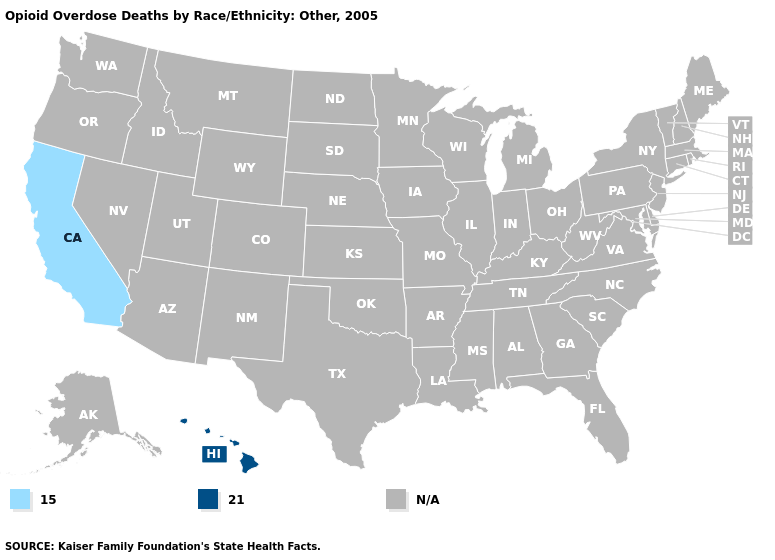What is the value of Louisiana?
Be succinct. N/A. What is the value of New York?
Concise answer only. N/A. What is the value of Alabama?
Answer briefly. N/A. What is the lowest value in the West?
Write a very short answer. 15.0. What is the value of Alaska?
Be succinct. N/A. What is the highest value in the West ?
Keep it brief. 21.0. Does California have the highest value in the USA?
Quick response, please. No. Name the states that have a value in the range 15.0?
Answer briefly. California. Name the states that have a value in the range N/A?
Keep it brief. Alabama, Alaska, Arizona, Arkansas, Colorado, Connecticut, Delaware, Florida, Georgia, Idaho, Illinois, Indiana, Iowa, Kansas, Kentucky, Louisiana, Maine, Maryland, Massachusetts, Michigan, Minnesota, Mississippi, Missouri, Montana, Nebraska, Nevada, New Hampshire, New Jersey, New Mexico, New York, North Carolina, North Dakota, Ohio, Oklahoma, Oregon, Pennsylvania, Rhode Island, South Carolina, South Dakota, Tennessee, Texas, Utah, Vermont, Virginia, Washington, West Virginia, Wisconsin, Wyoming. What is the value of Hawaii?
Concise answer only. 21.0. What is the lowest value in the USA?
Quick response, please. 15.0. Does the first symbol in the legend represent the smallest category?
Give a very brief answer. Yes. What is the value of Michigan?
Write a very short answer. N/A. What is the value of Connecticut?
Give a very brief answer. N/A. 